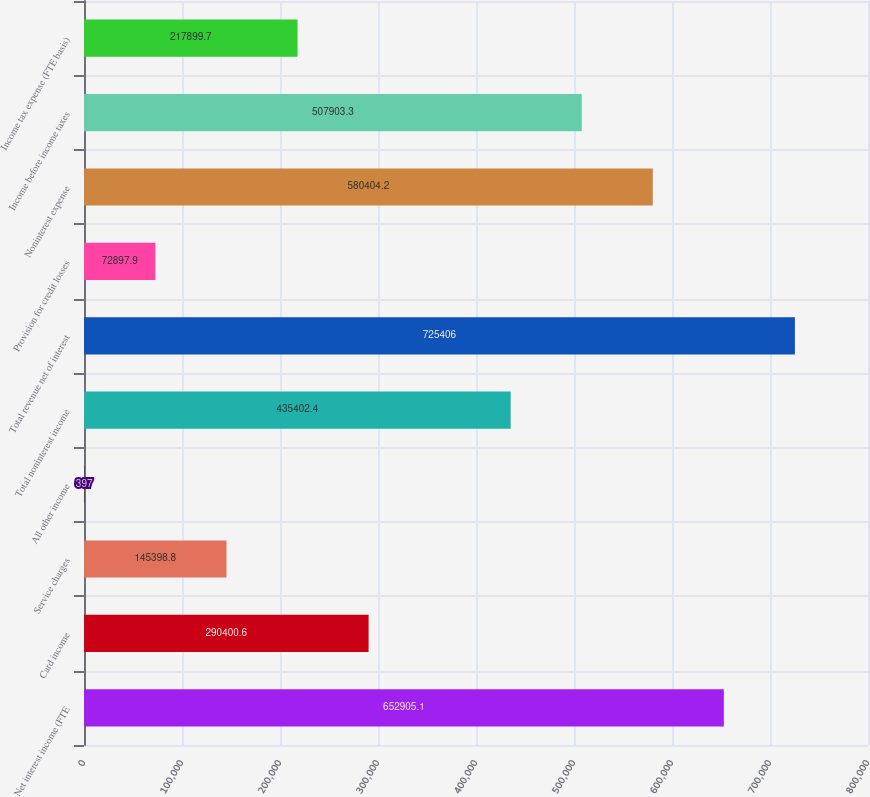Convert chart to OTSL. <chart><loc_0><loc_0><loc_500><loc_500><bar_chart><fcel>Net interest income (FTE<fcel>Card income<fcel>Service charges<fcel>All other income<fcel>Total noninterest income<fcel>Total revenue net of interest<fcel>Provision for credit losses<fcel>Noninterest expense<fcel>Income before income taxes<fcel>Income tax expense (FTE basis)<nl><fcel>652905<fcel>290401<fcel>145399<fcel>397<fcel>435402<fcel>725406<fcel>72897.9<fcel>580404<fcel>507903<fcel>217900<nl></chart> 